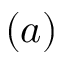Convert formula to latex. <formula><loc_0><loc_0><loc_500><loc_500>( a )</formula> 